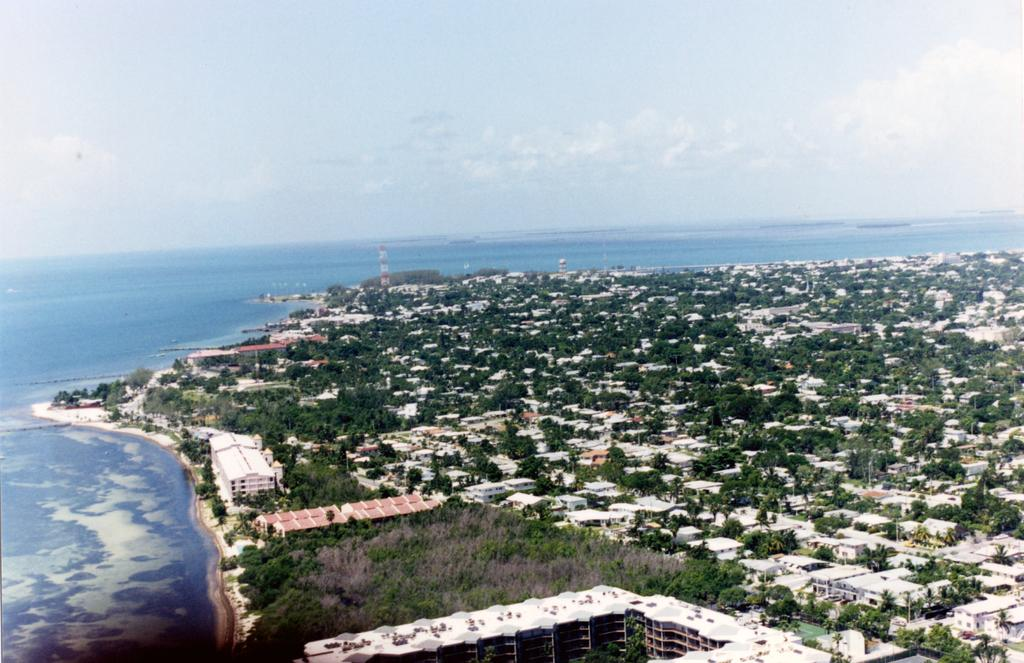What type of terrain is on the right side of the image? There is land on the right side of the image. What is on the opposite side of the land? There is water on the left side of the image. What structures can be seen on the land? There are buildings on the land. What type of vegetation is present on the land? There are plants and trees on the land. What is visible in the background of the image? There is a sky visible in the image, with clouds present. What type of sofa can be seen in the water on the left side of the image? There is no sofa present in the image; it features land on the right and water on the left. What type of milk is being used to make the eggnog in the image? There is no eggnog or milk present in the image; it focuses on land, water, buildings, plants, trees, and the sky. 